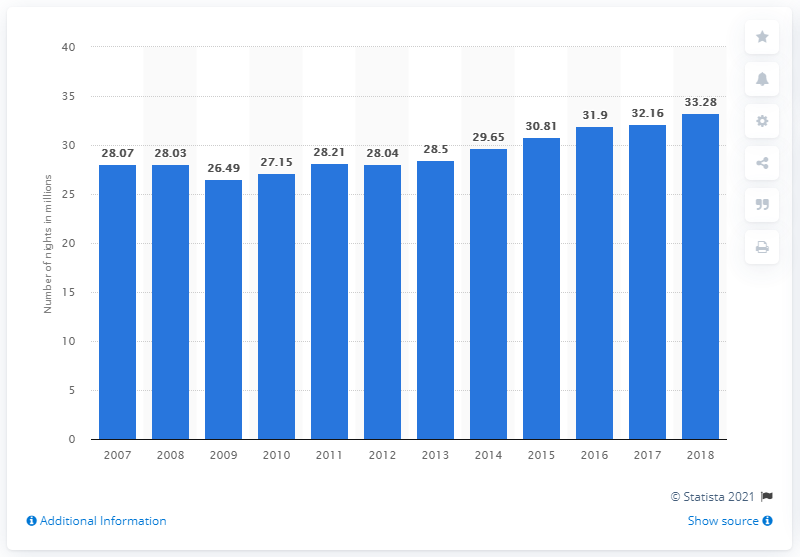Specify some key components in this picture. During the period of 2007 to 2018, a total of 33.28 nights were spent at tourist accommodation establishments in Denmark. In 2017, the number of nights spent at tourist accommodations surpassed 33.28 million. 